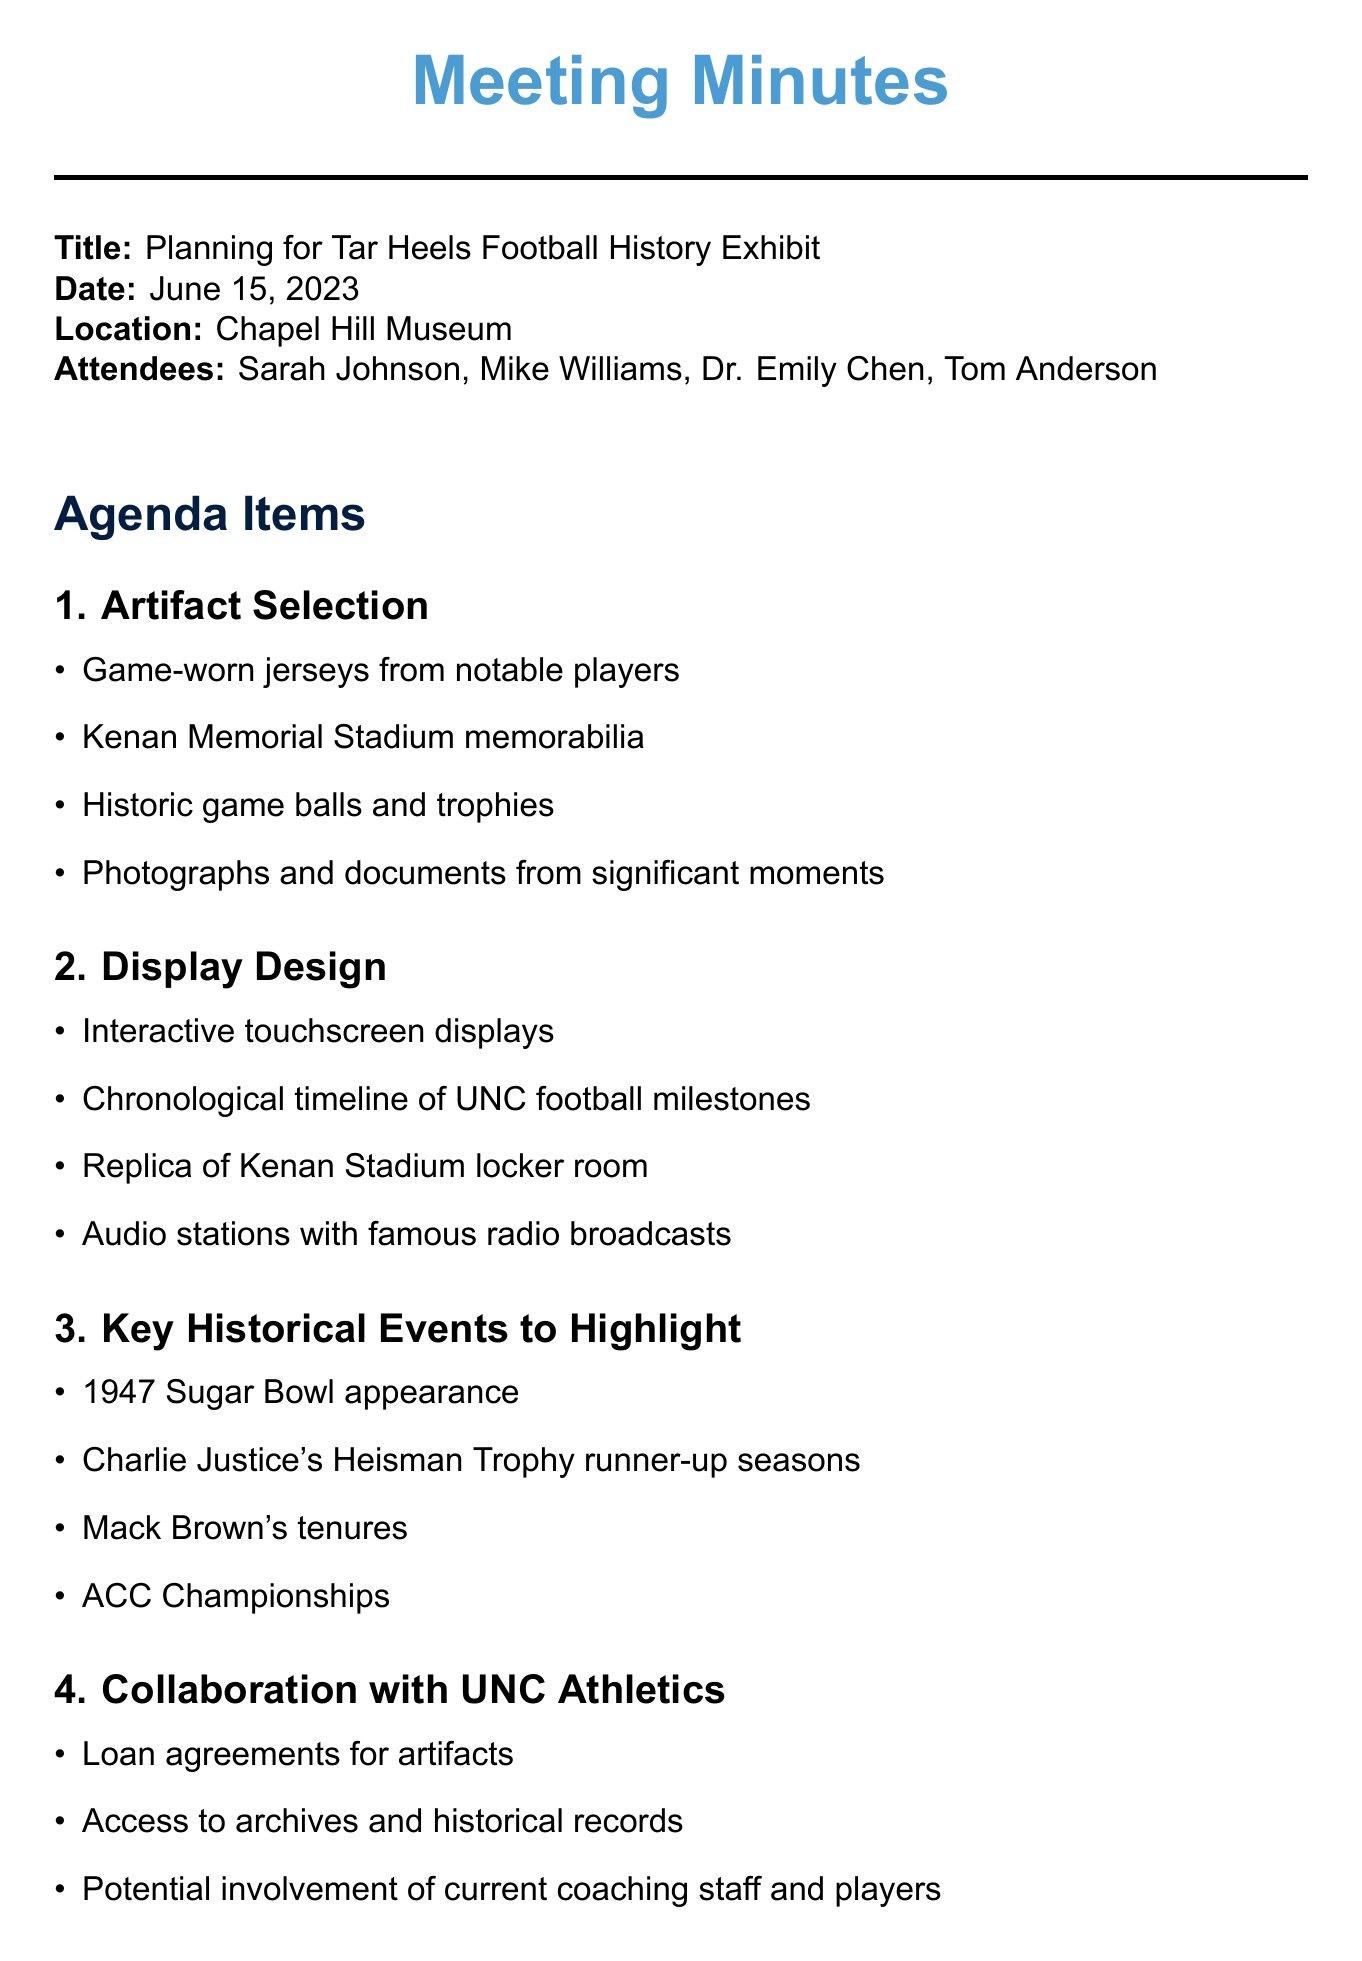What is the title of the meeting? The title of the meeting is stated at the beginning of the document under Title.
Answer: Planning for Tar Heels Football History Exhibit When was the meeting held? The date of the meeting is listed in the document under Date.
Answer: June 15, 2023 Who is the museum curator? Attendees are listed in the document; the museum curator is named specifically.
Answer: Sarah Johnson What is one artifact discussed for selection? The discussion points under Artifact Selection provide examples of artifacts considered.
Answer: Game-worn jerseys from notable players What collaboration is mentioned with UNC Athletics? The specific points of collaboration mentioned in the document under Collaboration with UNC Athletics reveal actions involved.
Answer: Loan agreements for artifacts What is the target opening date for the exhibit? The target opening date is noted in the Budget and Timeline section.
Answer: Before 2023 football season How many historical events are highlighted? The number of events is the length of the list under Key Historical Events to Highlight.
Answer: Four Who is responsible for creating a preliminary exhibit layout? The assignment of this task is listed in the Action Items section.
Answer: Tom What is the date of the next meeting? The next meeting date is specifically mentioned in the document at the end.
Answer: June 29, 2023 